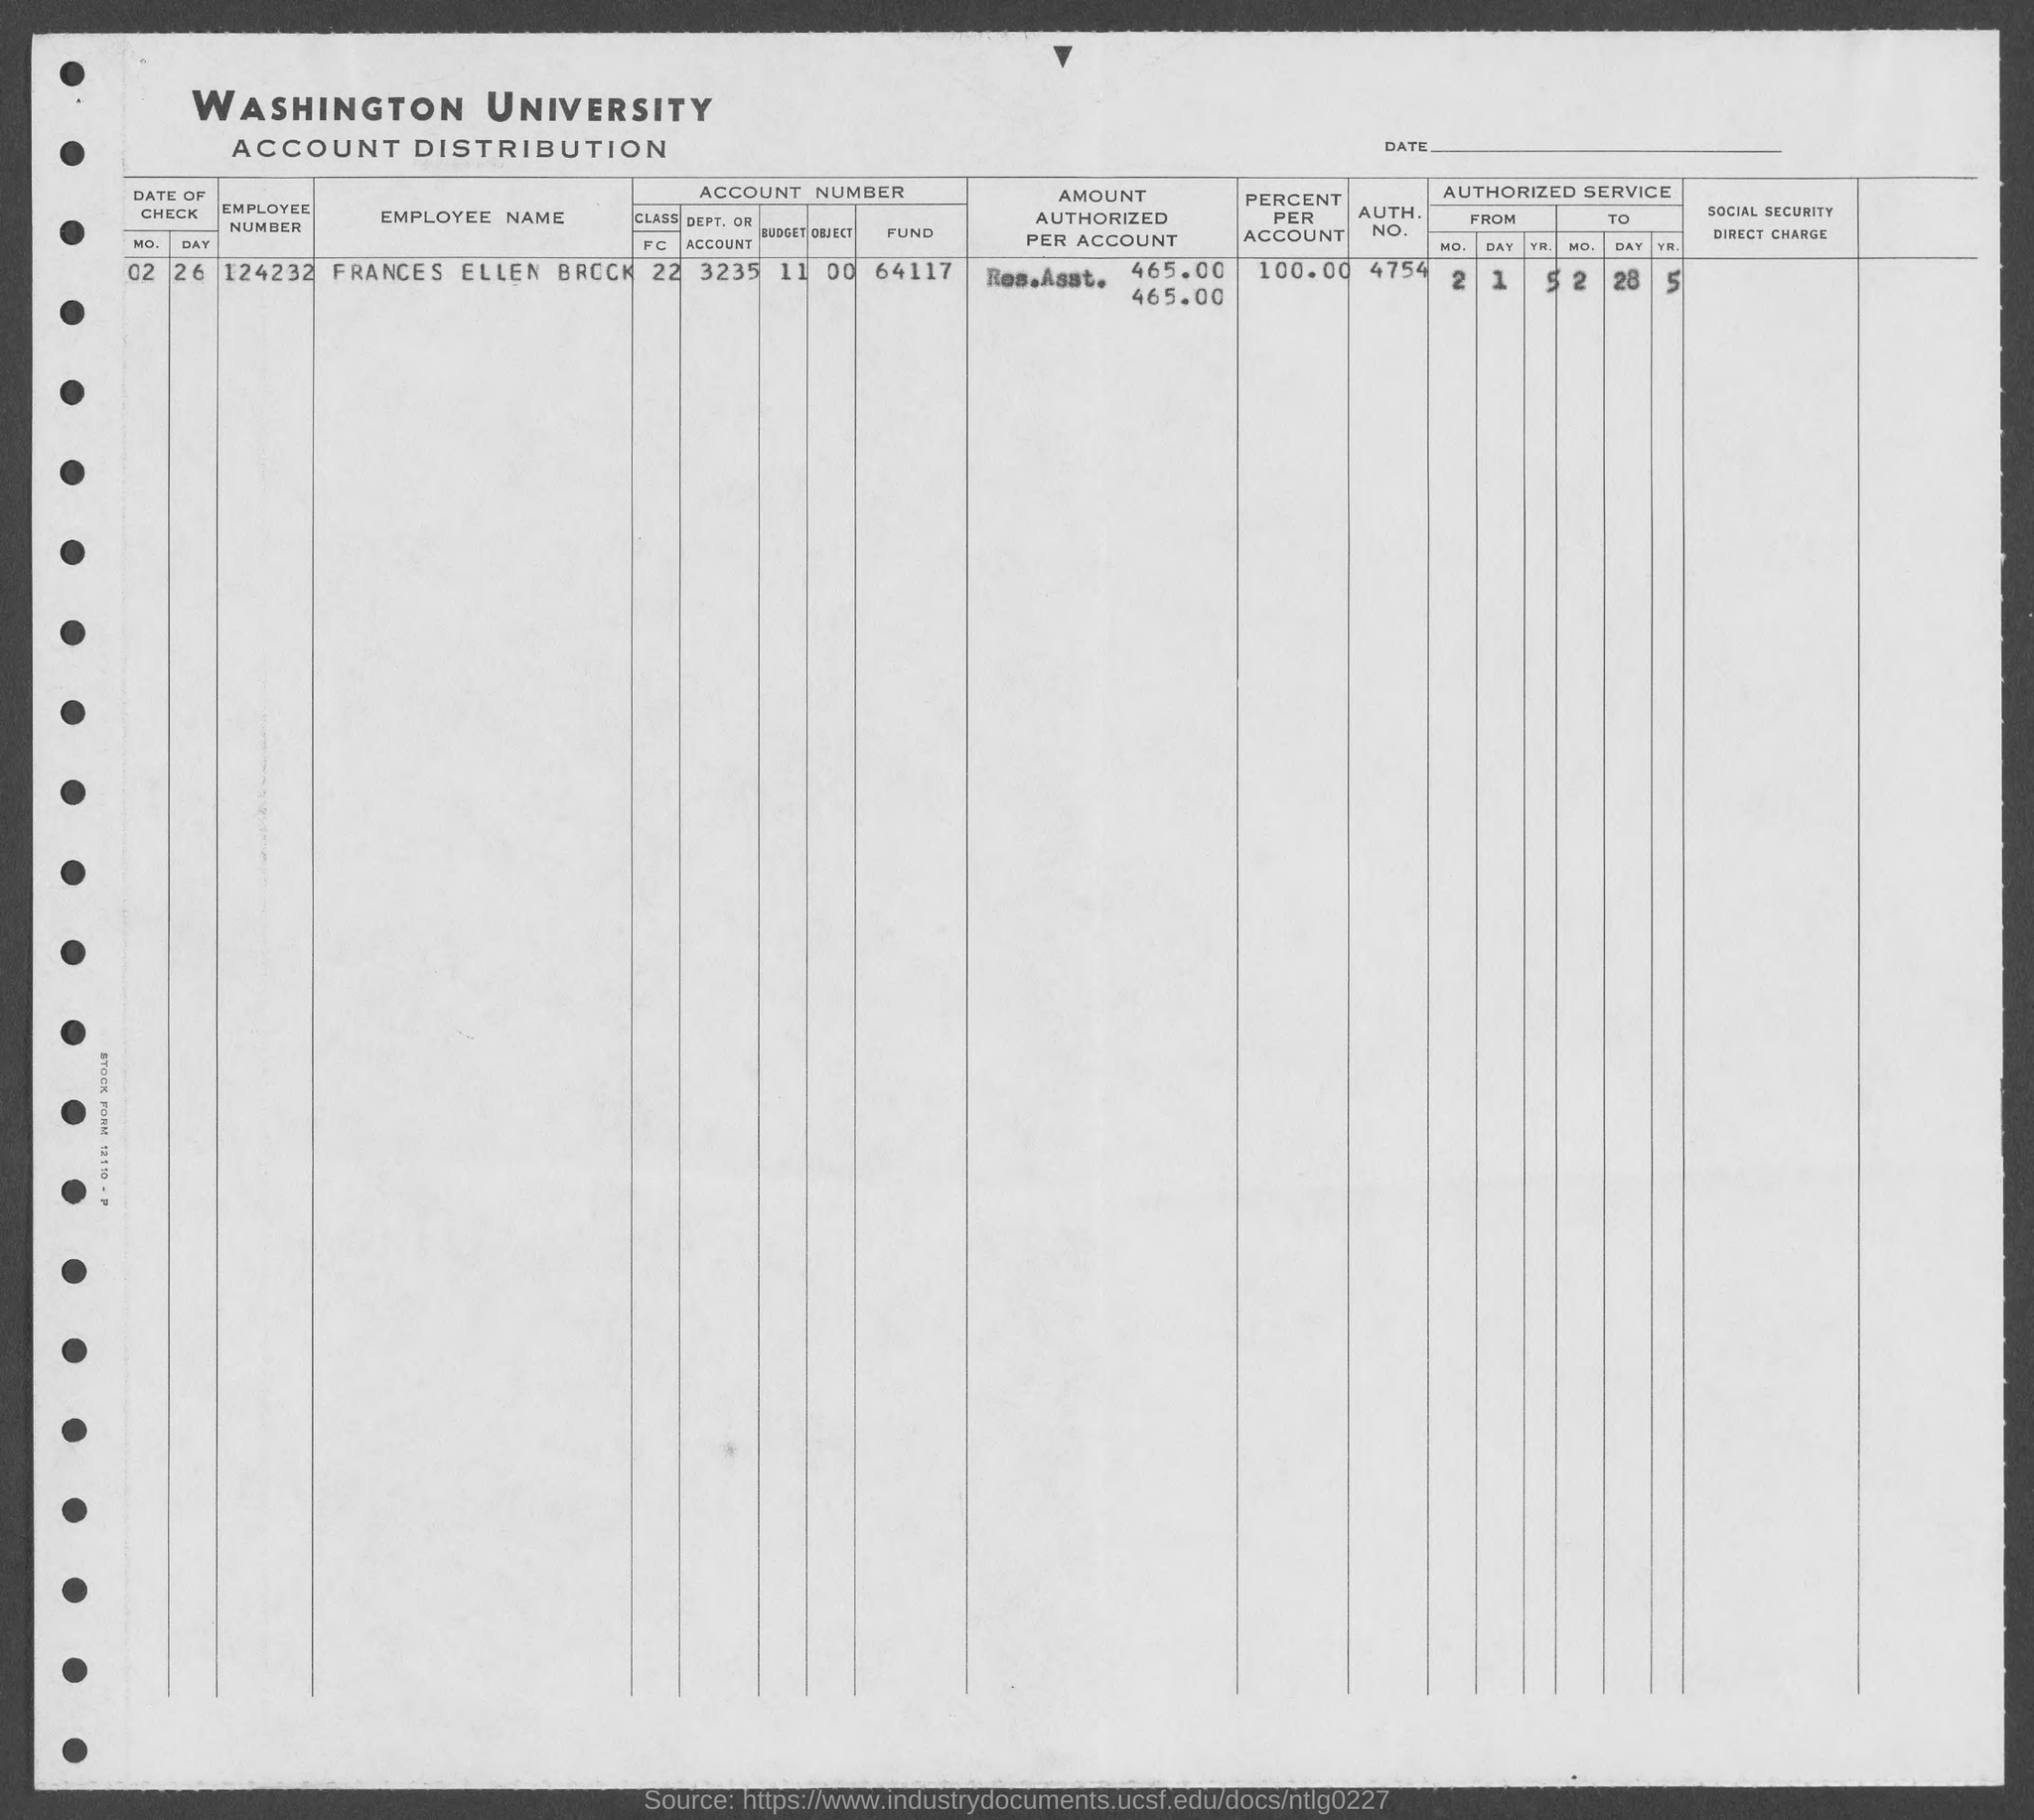Indicate a few pertinent items in this graphic. Frances Ellen Brock's percentage is 100.00%. The author is asking for information about someone named Frances Ellen Brock. Specifically, they are requesting the person's authorization number, which is 4754. The employee number of Frances Ellen Brock is 124232. 